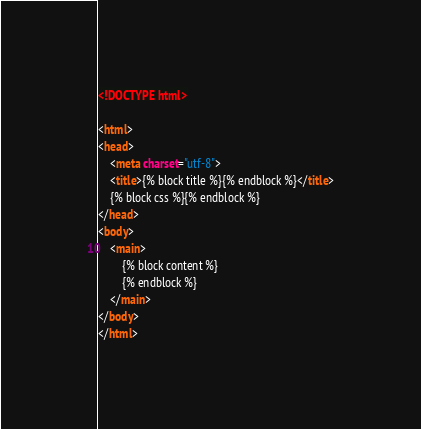Convert code to text. <code><loc_0><loc_0><loc_500><loc_500><_HTML_><!DOCTYPE html>

<html>
<head>
    <meta charset="utf-8">
    <title>{% block title %}{% endblock %}</title>
    {% block css %}{% endblock %}
</head>
<body>
    <main>
        {% block content %}
        {% endblock %}
    </main>
</body>
</html></code> 